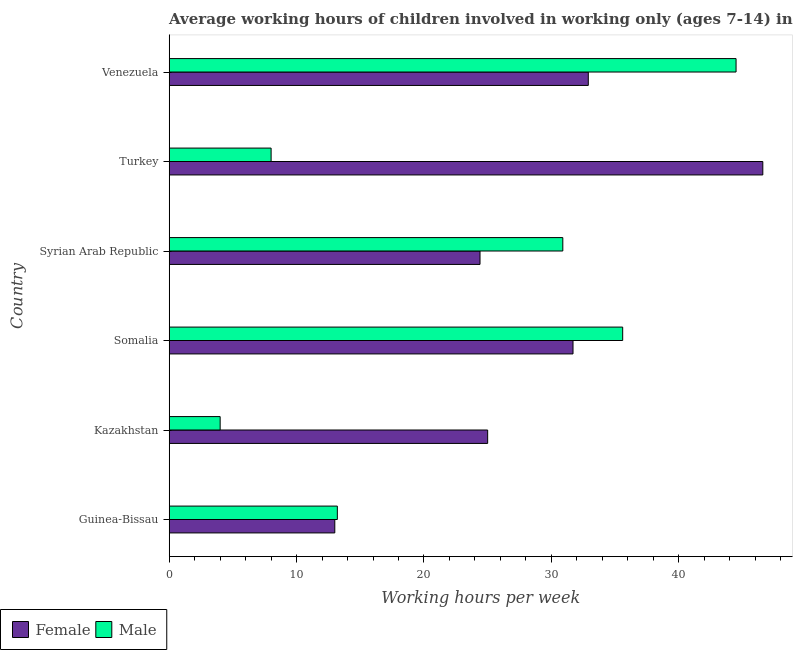How many different coloured bars are there?
Ensure brevity in your answer.  2. How many groups of bars are there?
Your response must be concise. 6. Are the number of bars per tick equal to the number of legend labels?
Give a very brief answer. Yes. How many bars are there on the 1st tick from the top?
Offer a terse response. 2. How many bars are there on the 2nd tick from the bottom?
Keep it short and to the point. 2. What is the label of the 6th group of bars from the top?
Keep it short and to the point. Guinea-Bissau. In how many cases, is the number of bars for a given country not equal to the number of legend labels?
Make the answer very short. 0. What is the average working hour of male children in Syrian Arab Republic?
Your answer should be compact. 30.9. Across all countries, what is the maximum average working hour of male children?
Your answer should be very brief. 44.5. In which country was the average working hour of male children maximum?
Give a very brief answer. Venezuela. In which country was the average working hour of female children minimum?
Your answer should be very brief. Guinea-Bissau. What is the total average working hour of female children in the graph?
Offer a terse response. 173.6. What is the average average working hour of female children per country?
Your answer should be compact. 28.93. What is the difference between the average working hour of female children and average working hour of male children in Venezuela?
Provide a succinct answer. -11.6. In how many countries, is the average working hour of male children greater than 8 hours?
Make the answer very short. 4. What is the ratio of the average working hour of female children in Guinea-Bissau to that in Turkey?
Ensure brevity in your answer.  0.28. Is the difference between the average working hour of female children in Kazakhstan and Somalia greater than the difference between the average working hour of male children in Kazakhstan and Somalia?
Give a very brief answer. Yes. What is the difference between the highest and the second highest average working hour of female children?
Your answer should be very brief. 13.7. What is the difference between the highest and the lowest average working hour of male children?
Offer a very short reply. 40.5. In how many countries, is the average working hour of female children greater than the average average working hour of female children taken over all countries?
Your answer should be compact. 3. What does the 2nd bar from the top in Syrian Arab Republic represents?
Ensure brevity in your answer.  Female. What does the 2nd bar from the bottom in Turkey represents?
Provide a short and direct response. Male. How many bars are there?
Provide a short and direct response. 12. Are all the bars in the graph horizontal?
Offer a terse response. Yes. What is the difference between two consecutive major ticks on the X-axis?
Your answer should be compact. 10. How many legend labels are there?
Provide a short and direct response. 2. What is the title of the graph?
Make the answer very short. Average working hours of children involved in working only (ages 7-14) in 2006. Does "Diarrhea" appear as one of the legend labels in the graph?
Your answer should be very brief. No. What is the label or title of the X-axis?
Provide a short and direct response. Working hours per week. What is the Working hours per week in Female in Guinea-Bissau?
Your answer should be compact. 13. What is the Working hours per week in Male in Guinea-Bissau?
Provide a short and direct response. 13.2. What is the Working hours per week of Female in Kazakhstan?
Provide a succinct answer. 25. What is the Working hours per week in Female in Somalia?
Keep it short and to the point. 31.7. What is the Working hours per week of Male in Somalia?
Give a very brief answer. 35.6. What is the Working hours per week in Female in Syrian Arab Republic?
Give a very brief answer. 24.4. What is the Working hours per week of Male in Syrian Arab Republic?
Ensure brevity in your answer.  30.9. What is the Working hours per week of Female in Turkey?
Offer a very short reply. 46.6. What is the Working hours per week of Male in Turkey?
Offer a very short reply. 8. What is the Working hours per week of Female in Venezuela?
Provide a short and direct response. 32.9. What is the Working hours per week in Male in Venezuela?
Make the answer very short. 44.5. Across all countries, what is the maximum Working hours per week of Female?
Make the answer very short. 46.6. Across all countries, what is the maximum Working hours per week in Male?
Ensure brevity in your answer.  44.5. Across all countries, what is the minimum Working hours per week of Female?
Offer a terse response. 13. Across all countries, what is the minimum Working hours per week of Male?
Your response must be concise. 4. What is the total Working hours per week in Female in the graph?
Provide a short and direct response. 173.6. What is the total Working hours per week in Male in the graph?
Offer a terse response. 136.2. What is the difference between the Working hours per week of Male in Guinea-Bissau and that in Kazakhstan?
Your answer should be compact. 9.2. What is the difference between the Working hours per week of Female in Guinea-Bissau and that in Somalia?
Offer a very short reply. -18.7. What is the difference between the Working hours per week in Male in Guinea-Bissau and that in Somalia?
Give a very brief answer. -22.4. What is the difference between the Working hours per week in Male in Guinea-Bissau and that in Syrian Arab Republic?
Your answer should be compact. -17.7. What is the difference between the Working hours per week in Female in Guinea-Bissau and that in Turkey?
Make the answer very short. -33.6. What is the difference between the Working hours per week in Female in Guinea-Bissau and that in Venezuela?
Make the answer very short. -19.9. What is the difference between the Working hours per week in Male in Guinea-Bissau and that in Venezuela?
Your response must be concise. -31.3. What is the difference between the Working hours per week of Male in Kazakhstan and that in Somalia?
Give a very brief answer. -31.6. What is the difference between the Working hours per week of Male in Kazakhstan and that in Syrian Arab Republic?
Make the answer very short. -26.9. What is the difference between the Working hours per week of Female in Kazakhstan and that in Turkey?
Offer a very short reply. -21.6. What is the difference between the Working hours per week of Male in Kazakhstan and that in Turkey?
Keep it short and to the point. -4. What is the difference between the Working hours per week of Female in Kazakhstan and that in Venezuela?
Offer a terse response. -7.9. What is the difference between the Working hours per week of Male in Kazakhstan and that in Venezuela?
Your answer should be very brief. -40.5. What is the difference between the Working hours per week of Female in Somalia and that in Syrian Arab Republic?
Your answer should be compact. 7.3. What is the difference between the Working hours per week in Male in Somalia and that in Syrian Arab Republic?
Offer a very short reply. 4.7. What is the difference between the Working hours per week of Female in Somalia and that in Turkey?
Keep it short and to the point. -14.9. What is the difference between the Working hours per week in Male in Somalia and that in Turkey?
Your answer should be very brief. 27.6. What is the difference between the Working hours per week in Female in Somalia and that in Venezuela?
Provide a succinct answer. -1.2. What is the difference between the Working hours per week of Female in Syrian Arab Republic and that in Turkey?
Provide a short and direct response. -22.2. What is the difference between the Working hours per week of Male in Syrian Arab Republic and that in Turkey?
Make the answer very short. 22.9. What is the difference between the Working hours per week of Female in Syrian Arab Republic and that in Venezuela?
Offer a very short reply. -8.5. What is the difference between the Working hours per week of Male in Syrian Arab Republic and that in Venezuela?
Offer a terse response. -13.6. What is the difference between the Working hours per week in Female in Turkey and that in Venezuela?
Your response must be concise. 13.7. What is the difference between the Working hours per week of Male in Turkey and that in Venezuela?
Keep it short and to the point. -36.5. What is the difference between the Working hours per week in Female in Guinea-Bissau and the Working hours per week in Male in Somalia?
Keep it short and to the point. -22.6. What is the difference between the Working hours per week in Female in Guinea-Bissau and the Working hours per week in Male in Syrian Arab Republic?
Ensure brevity in your answer.  -17.9. What is the difference between the Working hours per week of Female in Guinea-Bissau and the Working hours per week of Male in Venezuela?
Provide a succinct answer. -31.5. What is the difference between the Working hours per week of Female in Kazakhstan and the Working hours per week of Male in Somalia?
Offer a very short reply. -10.6. What is the difference between the Working hours per week in Female in Kazakhstan and the Working hours per week in Male in Venezuela?
Your answer should be very brief. -19.5. What is the difference between the Working hours per week in Female in Somalia and the Working hours per week in Male in Syrian Arab Republic?
Offer a very short reply. 0.8. What is the difference between the Working hours per week of Female in Somalia and the Working hours per week of Male in Turkey?
Keep it short and to the point. 23.7. What is the difference between the Working hours per week in Female in Somalia and the Working hours per week in Male in Venezuela?
Your response must be concise. -12.8. What is the difference between the Working hours per week of Female in Syrian Arab Republic and the Working hours per week of Male in Venezuela?
Provide a short and direct response. -20.1. What is the average Working hours per week of Female per country?
Your answer should be very brief. 28.93. What is the average Working hours per week of Male per country?
Ensure brevity in your answer.  22.7. What is the difference between the Working hours per week of Female and Working hours per week of Male in Guinea-Bissau?
Offer a very short reply. -0.2. What is the difference between the Working hours per week in Female and Working hours per week in Male in Somalia?
Give a very brief answer. -3.9. What is the difference between the Working hours per week in Female and Working hours per week in Male in Turkey?
Offer a terse response. 38.6. What is the difference between the Working hours per week in Female and Working hours per week in Male in Venezuela?
Ensure brevity in your answer.  -11.6. What is the ratio of the Working hours per week in Female in Guinea-Bissau to that in Kazakhstan?
Your answer should be compact. 0.52. What is the ratio of the Working hours per week in Female in Guinea-Bissau to that in Somalia?
Provide a short and direct response. 0.41. What is the ratio of the Working hours per week of Male in Guinea-Bissau to that in Somalia?
Offer a very short reply. 0.37. What is the ratio of the Working hours per week of Female in Guinea-Bissau to that in Syrian Arab Republic?
Your answer should be very brief. 0.53. What is the ratio of the Working hours per week of Male in Guinea-Bissau to that in Syrian Arab Republic?
Give a very brief answer. 0.43. What is the ratio of the Working hours per week in Female in Guinea-Bissau to that in Turkey?
Your response must be concise. 0.28. What is the ratio of the Working hours per week in Male in Guinea-Bissau to that in Turkey?
Your answer should be very brief. 1.65. What is the ratio of the Working hours per week in Female in Guinea-Bissau to that in Venezuela?
Your response must be concise. 0.4. What is the ratio of the Working hours per week in Male in Guinea-Bissau to that in Venezuela?
Your answer should be compact. 0.3. What is the ratio of the Working hours per week in Female in Kazakhstan to that in Somalia?
Make the answer very short. 0.79. What is the ratio of the Working hours per week of Male in Kazakhstan to that in Somalia?
Keep it short and to the point. 0.11. What is the ratio of the Working hours per week of Female in Kazakhstan to that in Syrian Arab Republic?
Make the answer very short. 1.02. What is the ratio of the Working hours per week of Male in Kazakhstan to that in Syrian Arab Republic?
Offer a terse response. 0.13. What is the ratio of the Working hours per week in Female in Kazakhstan to that in Turkey?
Your answer should be very brief. 0.54. What is the ratio of the Working hours per week in Female in Kazakhstan to that in Venezuela?
Your response must be concise. 0.76. What is the ratio of the Working hours per week of Male in Kazakhstan to that in Venezuela?
Your response must be concise. 0.09. What is the ratio of the Working hours per week of Female in Somalia to that in Syrian Arab Republic?
Make the answer very short. 1.3. What is the ratio of the Working hours per week of Male in Somalia to that in Syrian Arab Republic?
Your answer should be compact. 1.15. What is the ratio of the Working hours per week in Female in Somalia to that in Turkey?
Your answer should be very brief. 0.68. What is the ratio of the Working hours per week of Male in Somalia to that in Turkey?
Your answer should be very brief. 4.45. What is the ratio of the Working hours per week in Female in Somalia to that in Venezuela?
Give a very brief answer. 0.96. What is the ratio of the Working hours per week of Female in Syrian Arab Republic to that in Turkey?
Keep it short and to the point. 0.52. What is the ratio of the Working hours per week in Male in Syrian Arab Republic to that in Turkey?
Your response must be concise. 3.86. What is the ratio of the Working hours per week in Female in Syrian Arab Republic to that in Venezuela?
Make the answer very short. 0.74. What is the ratio of the Working hours per week in Male in Syrian Arab Republic to that in Venezuela?
Keep it short and to the point. 0.69. What is the ratio of the Working hours per week in Female in Turkey to that in Venezuela?
Offer a very short reply. 1.42. What is the ratio of the Working hours per week in Male in Turkey to that in Venezuela?
Your answer should be compact. 0.18. What is the difference between the highest and the second highest Working hours per week of Female?
Your answer should be very brief. 13.7. What is the difference between the highest and the second highest Working hours per week of Male?
Keep it short and to the point. 8.9. What is the difference between the highest and the lowest Working hours per week in Female?
Your answer should be very brief. 33.6. What is the difference between the highest and the lowest Working hours per week of Male?
Keep it short and to the point. 40.5. 